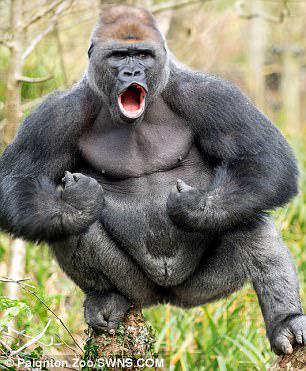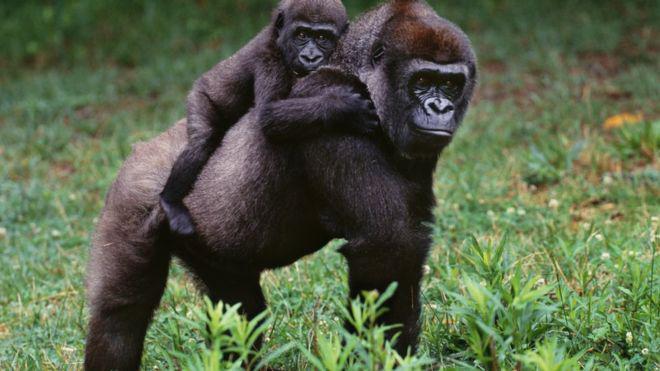The first image is the image on the left, the second image is the image on the right. Evaluate the accuracy of this statement regarding the images: "One of the images features a lone male.". Is it true? Answer yes or no. Yes. The first image is the image on the left, the second image is the image on the right. Assess this claim about the two images: "One gorilla is carrying a baby gorilla on its back.". Correct or not? Answer yes or no. Yes. 